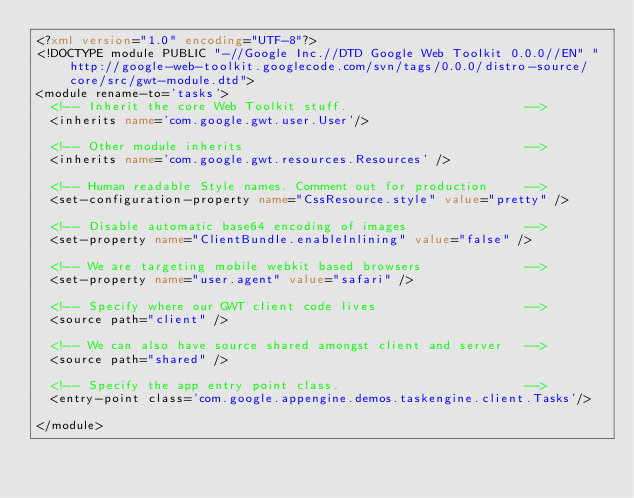<code> <loc_0><loc_0><loc_500><loc_500><_XML_><?xml version="1.0" encoding="UTF-8"?>
<!DOCTYPE module PUBLIC "-//Google Inc.//DTD Google Web Toolkit 0.0.0//EN" "http://google-web-toolkit.googlecode.com/svn/tags/0.0.0/distro-source/core/src/gwt-module.dtd">
<module rename-to='tasks'>
  <!-- Inherit the core Web Toolkit stuff.                        -->
  <inherits name='com.google.gwt.user.User'/>

  <!-- Other module inherits                                      -->
  <inherits name='com.google.gwt.resources.Resources' />
 
  <!-- Human readable Style names. Comment out for production     -->     
  <set-configuration-property name="CssResource.style" value="pretty" />              
  
  <!-- Disable automatic base64 encoding of images                -->
  <set-property name="ClientBundle.enableInlining" value="false" />

  <!-- We are targeting mobile webkit based browsers              -->  
  <set-property name="user.agent" value="safari" />  

  <!-- Specify where our GWT client code lives                    -->
  <source path="client" />

  <!-- We can also have source shared amongst client and server   -->
  <source path="shared" />  

  <!-- Specify the app entry point class.                         -->
  <entry-point class='com.google.appengine.demos.taskengine.client.Tasks'/>
  
</module>
</code> 